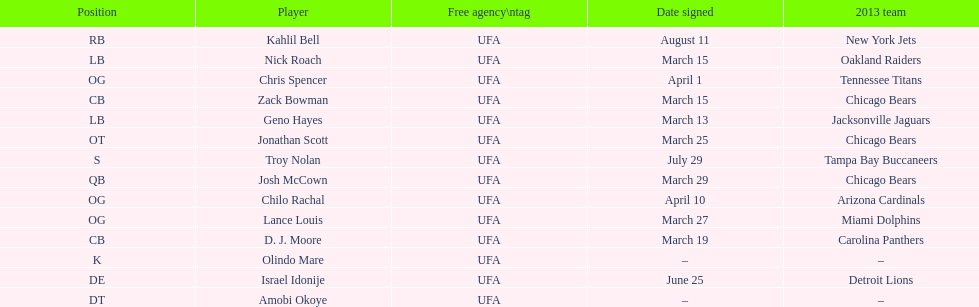How many players play cb or og? 5. Write the full table. {'header': ['Position', 'Player', 'Free agency\\ntag', 'Date signed', '2013 team'], 'rows': [['RB', 'Kahlil Bell', 'UFA', 'August 11', 'New York Jets'], ['LB', 'Nick Roach', 'UFA', 'March 15', 'Oakland Raiders'], ['OG', 'Chris Spencer', 'UFA', 'April 1', 'Tennessee Titans'], ['CB', 'Zack Bowman', 'UFA', 'March 15', 'Chicago Bears'], ['LB', 'Geno Hayes', 'UFA', 'March 13', 'Jacksonville Jaguars'], ['OT', 'Jonathan Scott', 'UFA', 'March 25', 'Chicago Bears'], ['S', 'Troy Nolan', 'UFA', 'July 29', 'Tampa Bay Buccaneers'], ['QB', 'Josh McCown', 'UFA', 'March 29', 'Chicago Bears'], ['OG', 'Chilo Rachal', 'UFA', 'April 10', 'Arizona Cardinals'], ['OG', 'Lance Louis', 'UFA', 'March 27', 'Miami Dolphins'], ['CB', 'D. J. Moore', 'UFA', 'March 19', 'Carolina Panthers'], ['K', 'Olindo Mare', 'UFA', '–', '–'], ['DE', 'Israel Idonije', 'UFA', 'June 25', 'Detroit Lions'], ['DT', 'Amobi Okoye', 'UFA', '–', '–']]} 